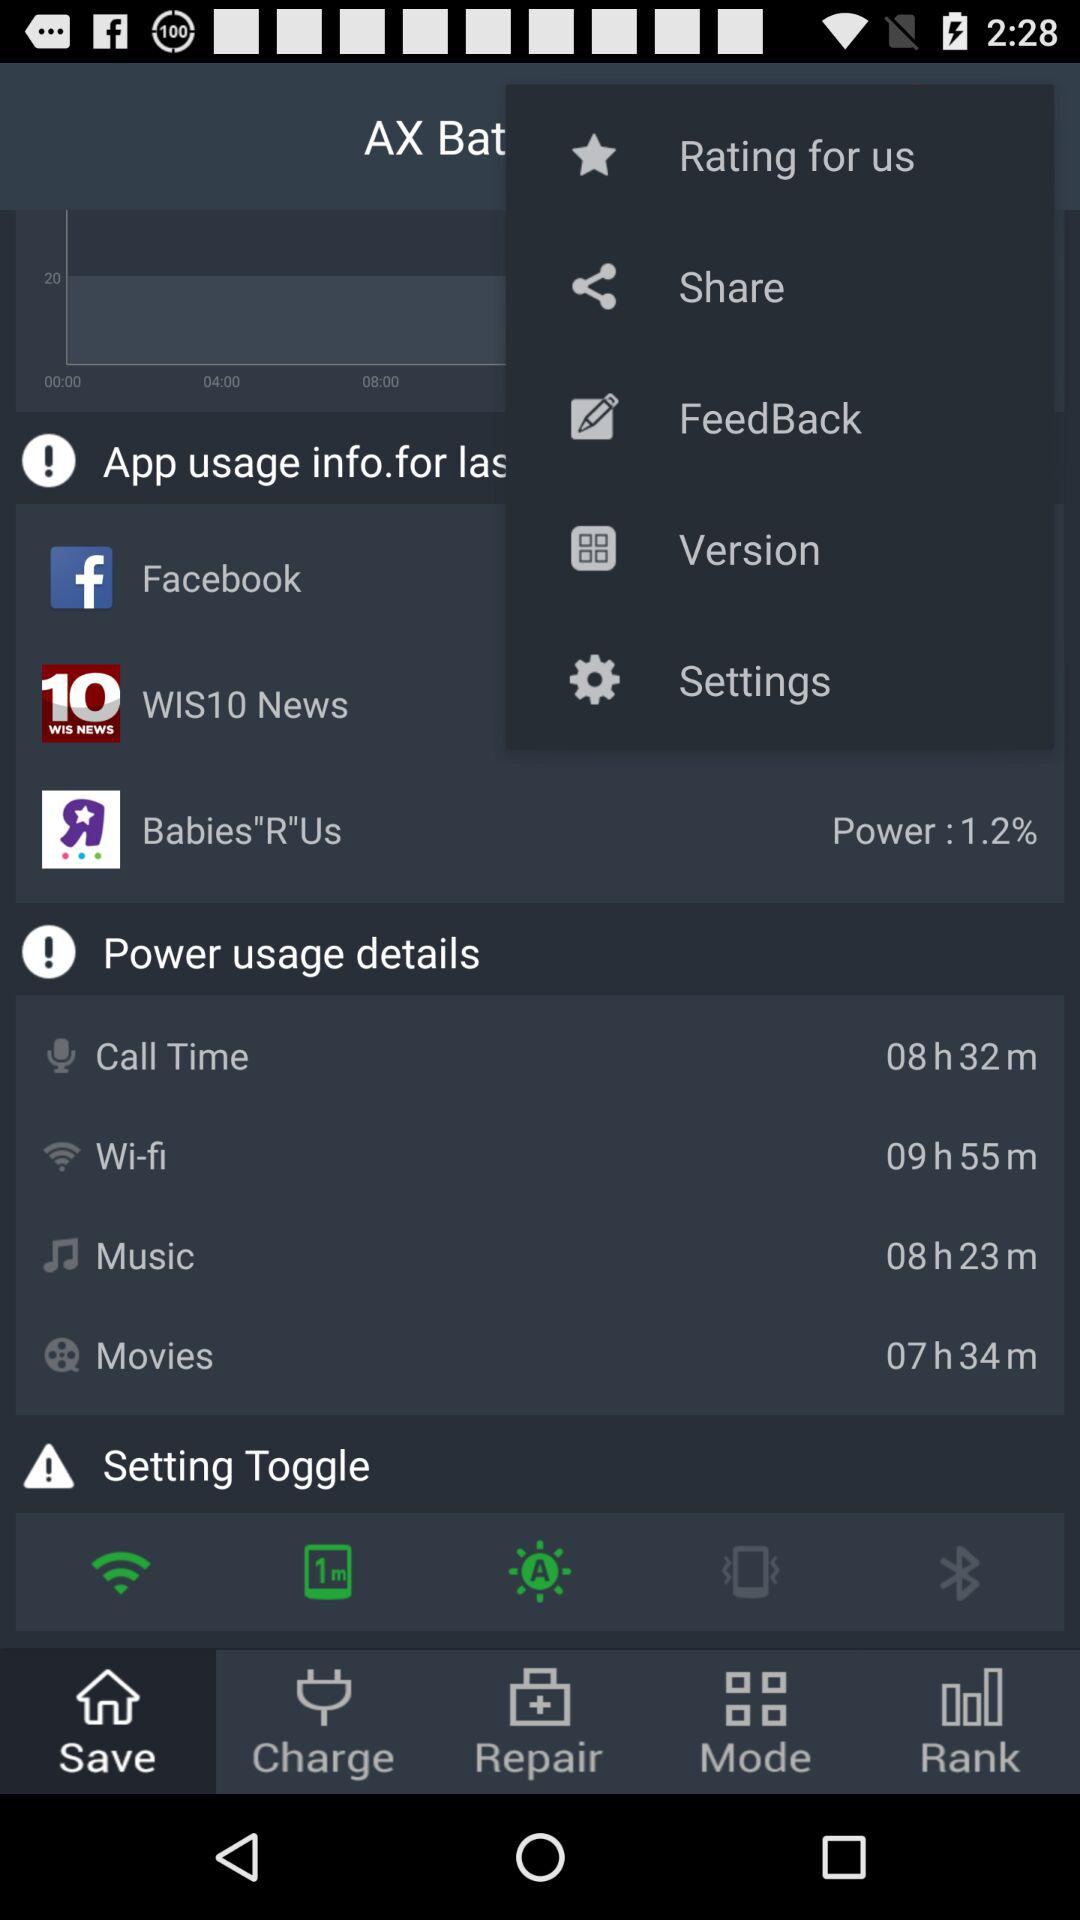What is the power percentage? The power percentage is 1.2. 